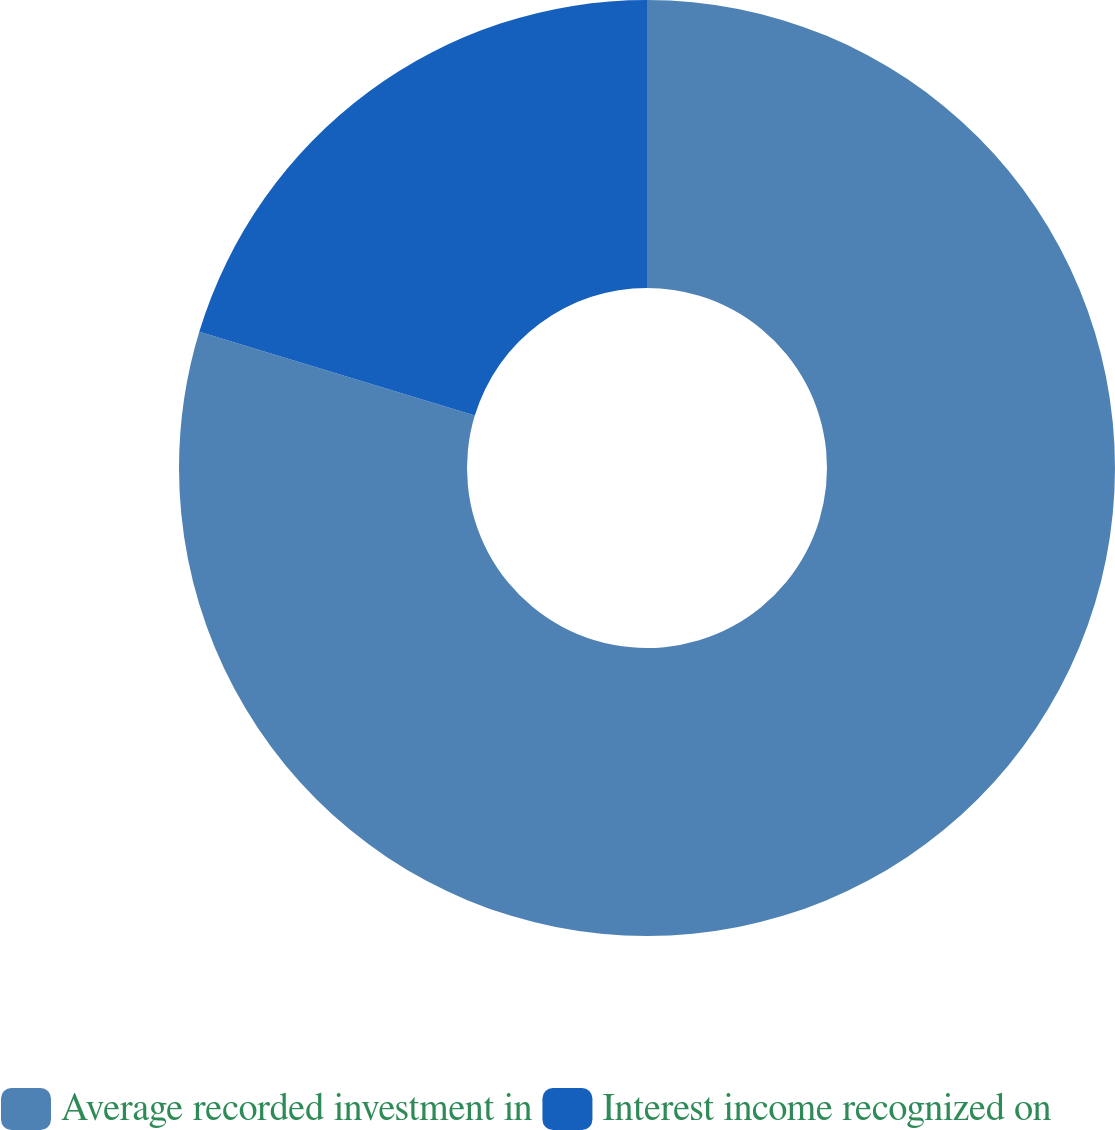<chart> <loc_0><loc_0><loc_500><loc_500><pie_chart><fcel>Average recorded investment in<fcel>Interest income recognized on<nl><fcel>79.7%<fcel>20.3%<nl></chart> 